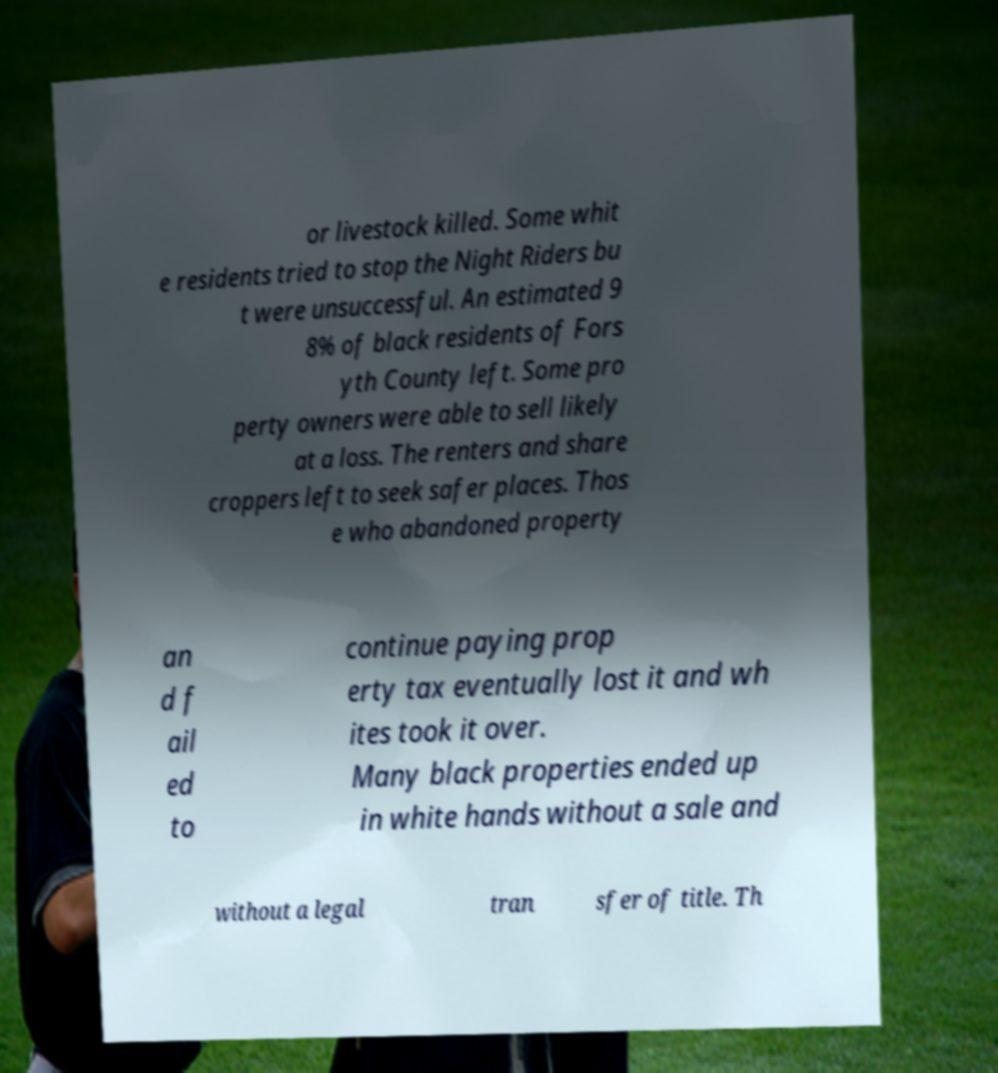Please identify and transcribe the text found in this image. or livestock killed. Some whit e residents tried to stop the Night Riders bu t were unsuccessful. An estimated 9 8% of black residents of Fors yth County left. Some pro perty owners were able to sell likely at a loss. The renters and share croppers left to seek safer places. Thos e who abandoned property an d f ail ed to continue paying prop erty tax eventually lost it and wh ites took it over. Many black properties ended up in white hands without a sale and without a legal tran sfer of title. Th 